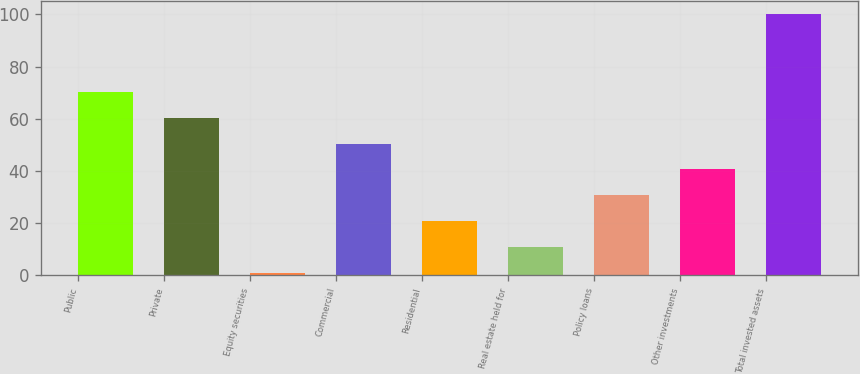<chart> <loc_0><loc_0><loc_500><loc_500><bar_chart><fcel>Public<fcel>Private<fcel>Equity securities<fcel>Commercial<fcel>Residential<fcel>Real estate held for<fcel>Policy loans<fcel>Other investments<fcel>Total invested assets<nl><fcel>70.3<fcel>60.4<fcel>1<fcel>50.5<fcel>20.8<fcel>10.9<fcel>30.7<fcel>40.6<fcel>100<nl></chart> 